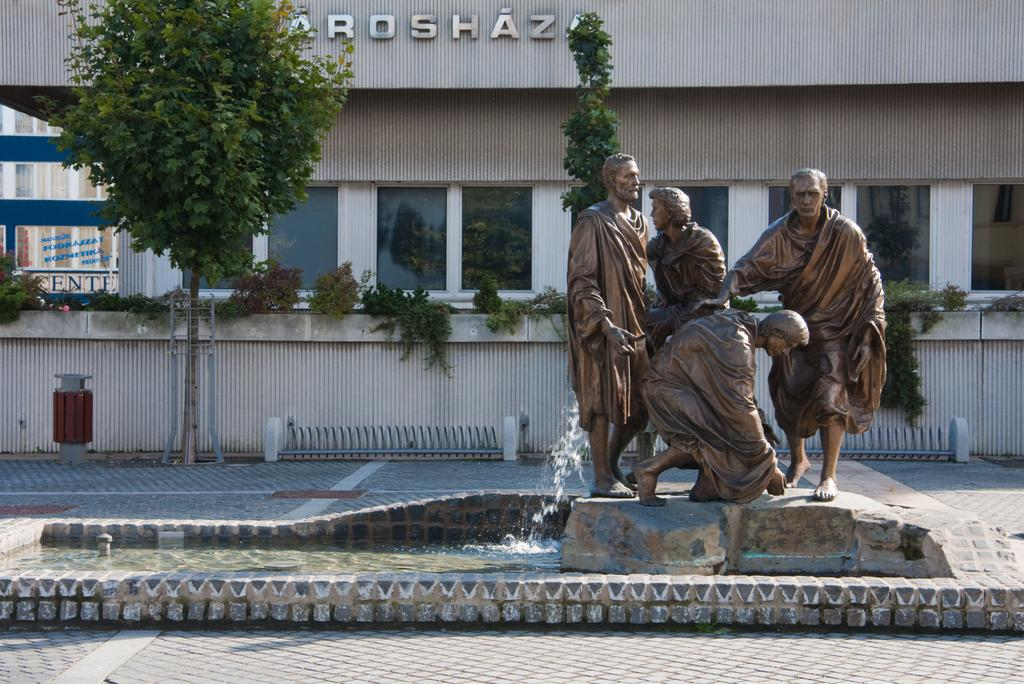Where was the picture taken? The picture was taken outside a city. What can be seen in the foreground of the image? There is a fountain, pavement, and a statue in the foreground of the image. What architectural features can be seen in the background of the image? There are windows, a door, and a building in the background of the image. What is the weather like in the image? It is sunny in the image. Can you see a kitten playing with a shock of electricity in the image? No, there is no kitten or shock of electricity present in the image. Is the image taken in a park? The provided facts do not mention a park, so we cannot determine if the image was taken in a park or not. 